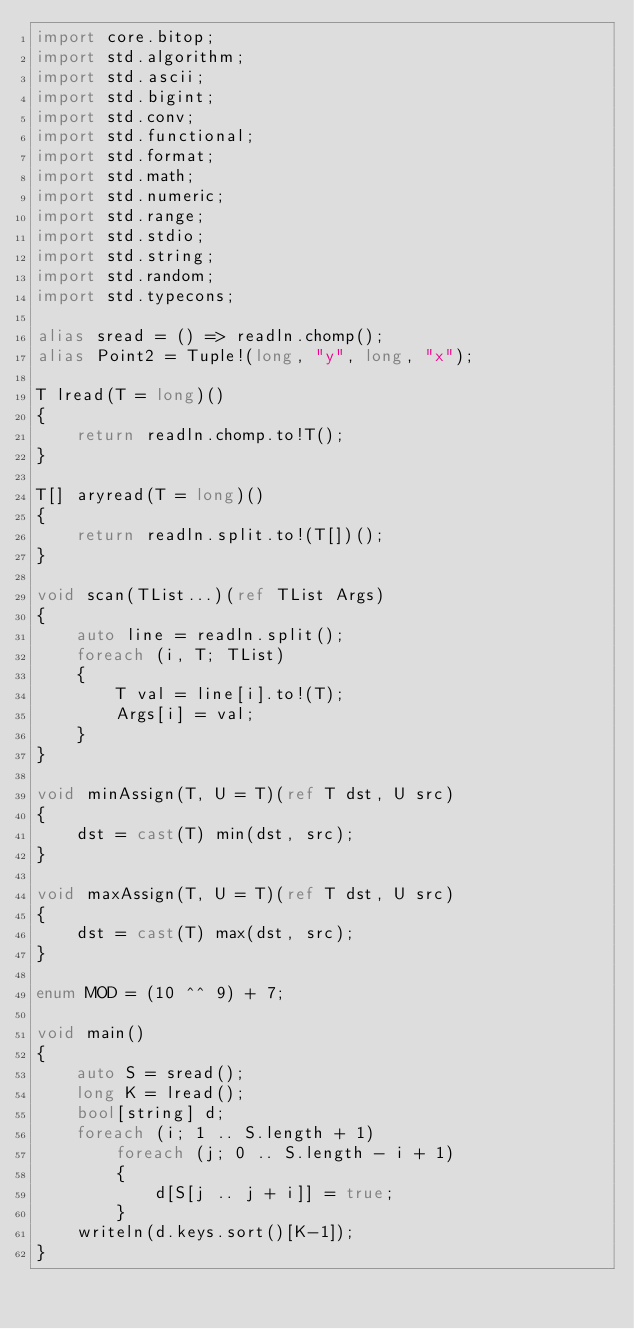<code> <loc_0><loc_0><loc_500><loc_500><_D_>import core.bitop;
import std.algorithm;
import std.ascii;
import std.bigint;
import std.conv;
import std.functional;
import std.format;
import std.math;
import std.numeric;
import std.range;
import std.stdio;
import std.string;
import std.random;
import std.typecons;

alias sread = () => readln.chomp();
alias Point2 = Tuple!(long, "y", long, "x");

T lread(T = long)()
{
    return readln.chomp.to!T();
}

T[] aryread(T = long)()
{
    return readln.split.to!(T[])();
}

void scan(TList...)(ref TList Args)
{
    auto line = readln.split();
    foreach (i, T; TList)
    {
        T val = line[i].to!(T);
        Args[i] = val;
    }
}

void minAssign(T, U = T)(ref T dst, U src)
{
    dst = cast(T) min(dst, src);
}

void maxAssign(T, U = T)(ref T dst, U src)
{
    dst = cast(T) max(dst, src);
}

enum MOD = (10 ^^ 9) + 7;

void main()
{
    auto S = sread();
    long K = lread();
    bool[string] d;
    foreach (i; 1 .. S.length + 1)
        foreach (j; 0 .. S.length - i + 1)
        {
            d[S[j .. j + i]] = true;
        }
    writeln(d.keys.sort()[K-1]);
}
</code> 